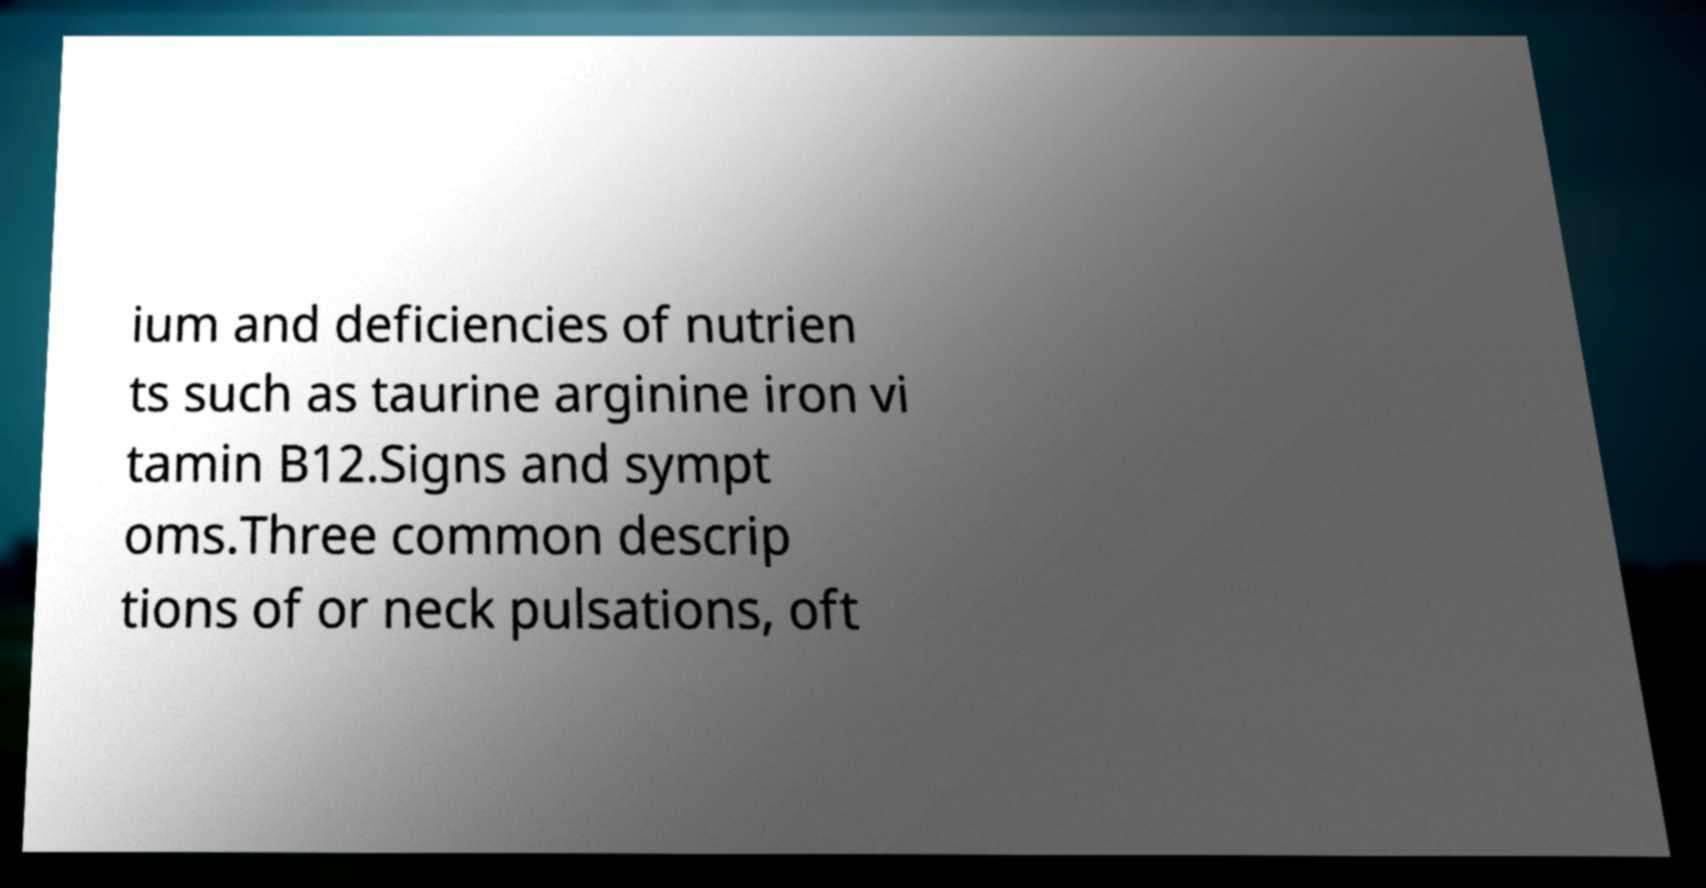Please read and relay the text visible in this image. What does it say? ium and deficiencies of nutrien ts such as taurine arginine iron vi tamin B12.Signs and sympt oms.Three common descrip tions of or neck pulsations, oft 